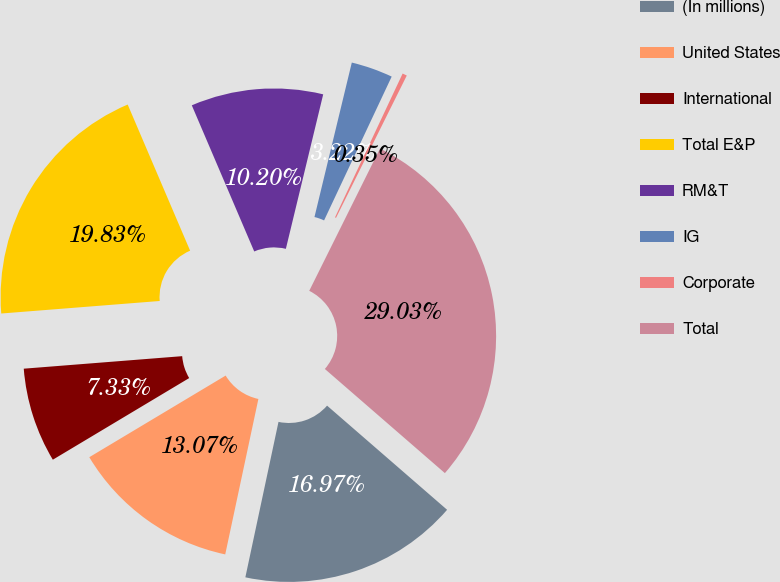Convert chart. <chart><loc_0><loc_0><loc_500><loc_500><pie_chart><fcel>(In millions)<fcel>United States<fcel>International<fcel>Total E&P<fcel>RM&T<fcel>IG<fcel>Corporate<fcel>Total<nl><fcel>16.97%<fcel>13.07%<fcel>7.33%<fcel>19.83%<fcel>10.2%<fcel>3.22%<fcel>0.35%<fcel>29.03%<nl></chart> 